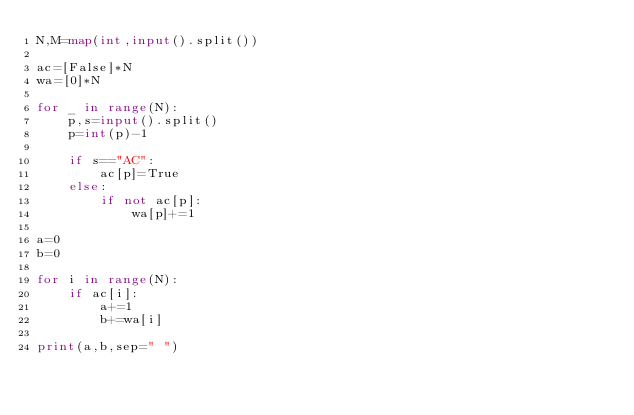Convert code to text. <code><loc_0><loc_0><loc_500><loc_500><_Python_>N,M=map(int,input().split())

ac=[False]*N
wa=[0]*N

for _ in range(N):
    p,s=input().split()
    p=int(p)-1

    if s=="AC":
        ac[p]=True
    else:
        if not ac[p]:
            wa[p]+=1

a=0
b=0

for i in range(N):
    if ac[i]:
        a+=1
        b+=wa[i]

print(a,b,sep=" ")
</code> 